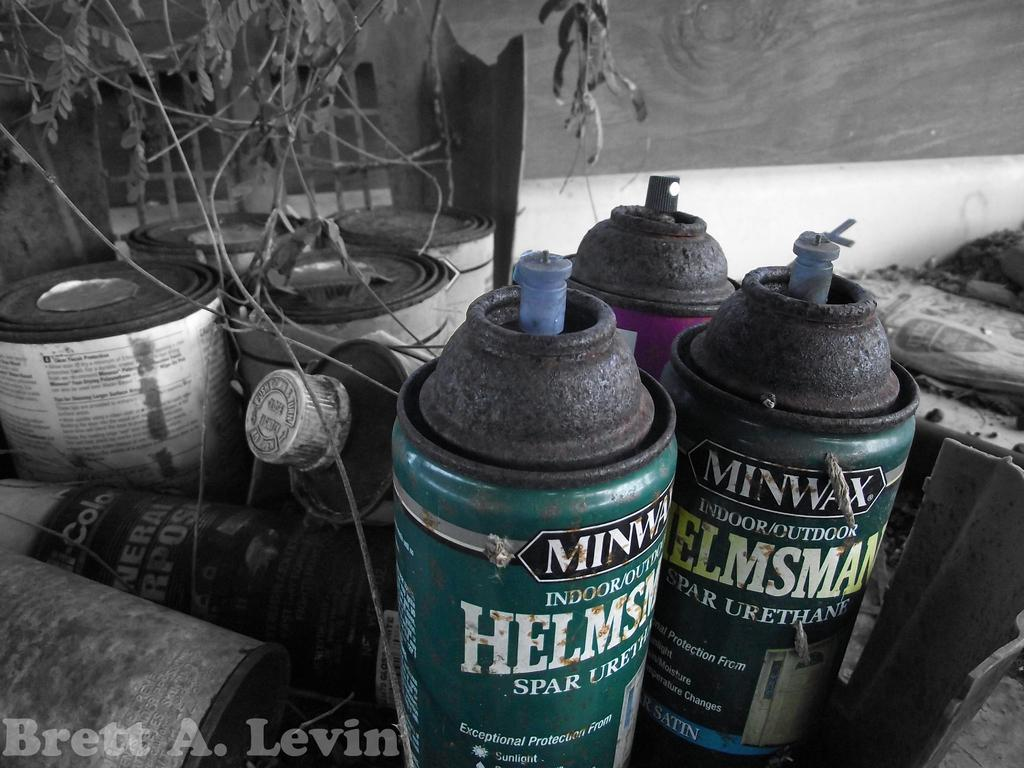<image>
Render a clear and concise summary of the photo. several cans of Helmsman MinWax sit rusting on a table 